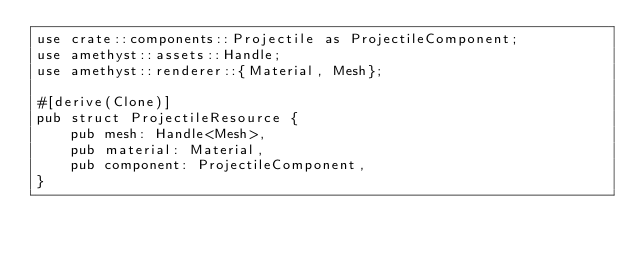<code> <loc_0><loc_0><loc_500><loc_500><_Rust_>use crate::components::Projectile as ProjectileComponent;
use amethyst::assets::Handle;
use amethyst::renderer::{Material, Mesh};

#[derive(Clone)]
pub struct ProjectileResource {
    pub mesh: Handle<Mesh>,
    pub material: Material,
    pub component: ProjectileComponent,
}
</code> 